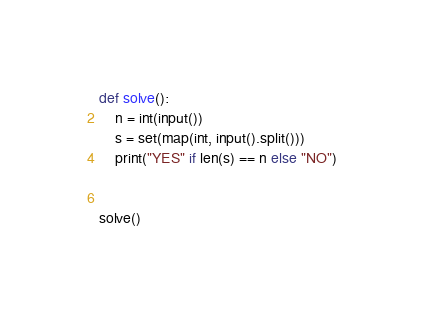<code> <loc_0><loc_0><loc_500><loc_500><_Python_>def solve():
    n = int(input())
    s = set(map(int, input().split()))
    print("YES" if len(s) == n else "NO")


solve()
</code> 